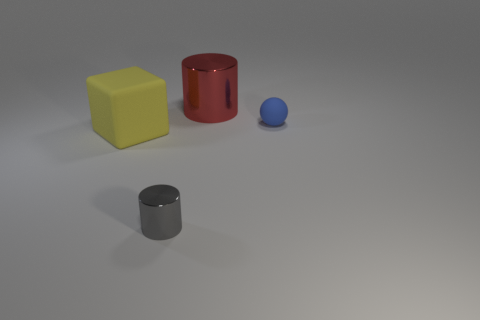How many small gray objects are the same shape as the red shiny thing?
Make the answer very short. 1. The red shiny thing has what shape?
Keep it short and to the point. Cylinder. Is the number of large cylinders behind the big red metal object the same as the number of red cylinders?
Ensure brevity in your answer.  No. Does the big object left of the gray cylinder have the same material as the red cylinder?
Give a very brief answer. No. Is the number of small shiny cylinders that are behind the gray metal thing less than the number of purple things?
Make the answer very short. No. How many shiny things are either gray cylinders or big cylinders?
Make the answer very short. 2. Is there anything else that is the same color as the block?
Your answer should be very brief. No. There is a shiny thing that is in front of the blue sphere; is it the same shape as the shiny object that is behind the tiny sphere?
Your answer should be very brief. Yes. What number of objects are big red cylinders or cylinders that are behind the large yellow block?
Ensure brevity in your answer.  1. What number of other objects are the same size as the red shiny object?
Your answer should be compact. 1. 